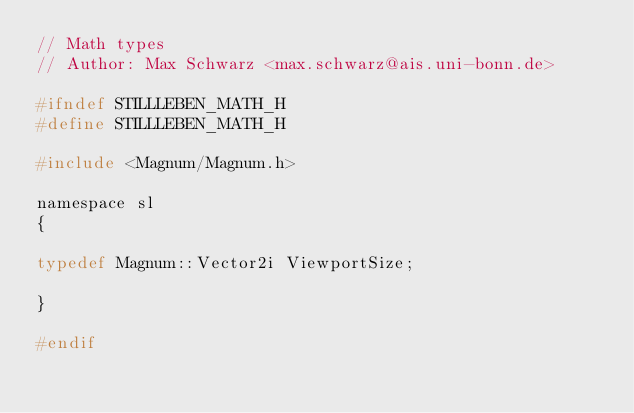<code> <loc_0><loc_0><loc_500><loc_500><_C_>// Math types
// Author: Max Schwarz <max.schwarz@ais.uni-bonn.de>

#ifndef STILLLEBEN_MATH_H
#define STILLLEBEN_MATH_H

#include <Magnum/Magnum.h>

namespace sl
{

typedef Magnum::Vector2i ViewportSize;

}

#endif
</code> 